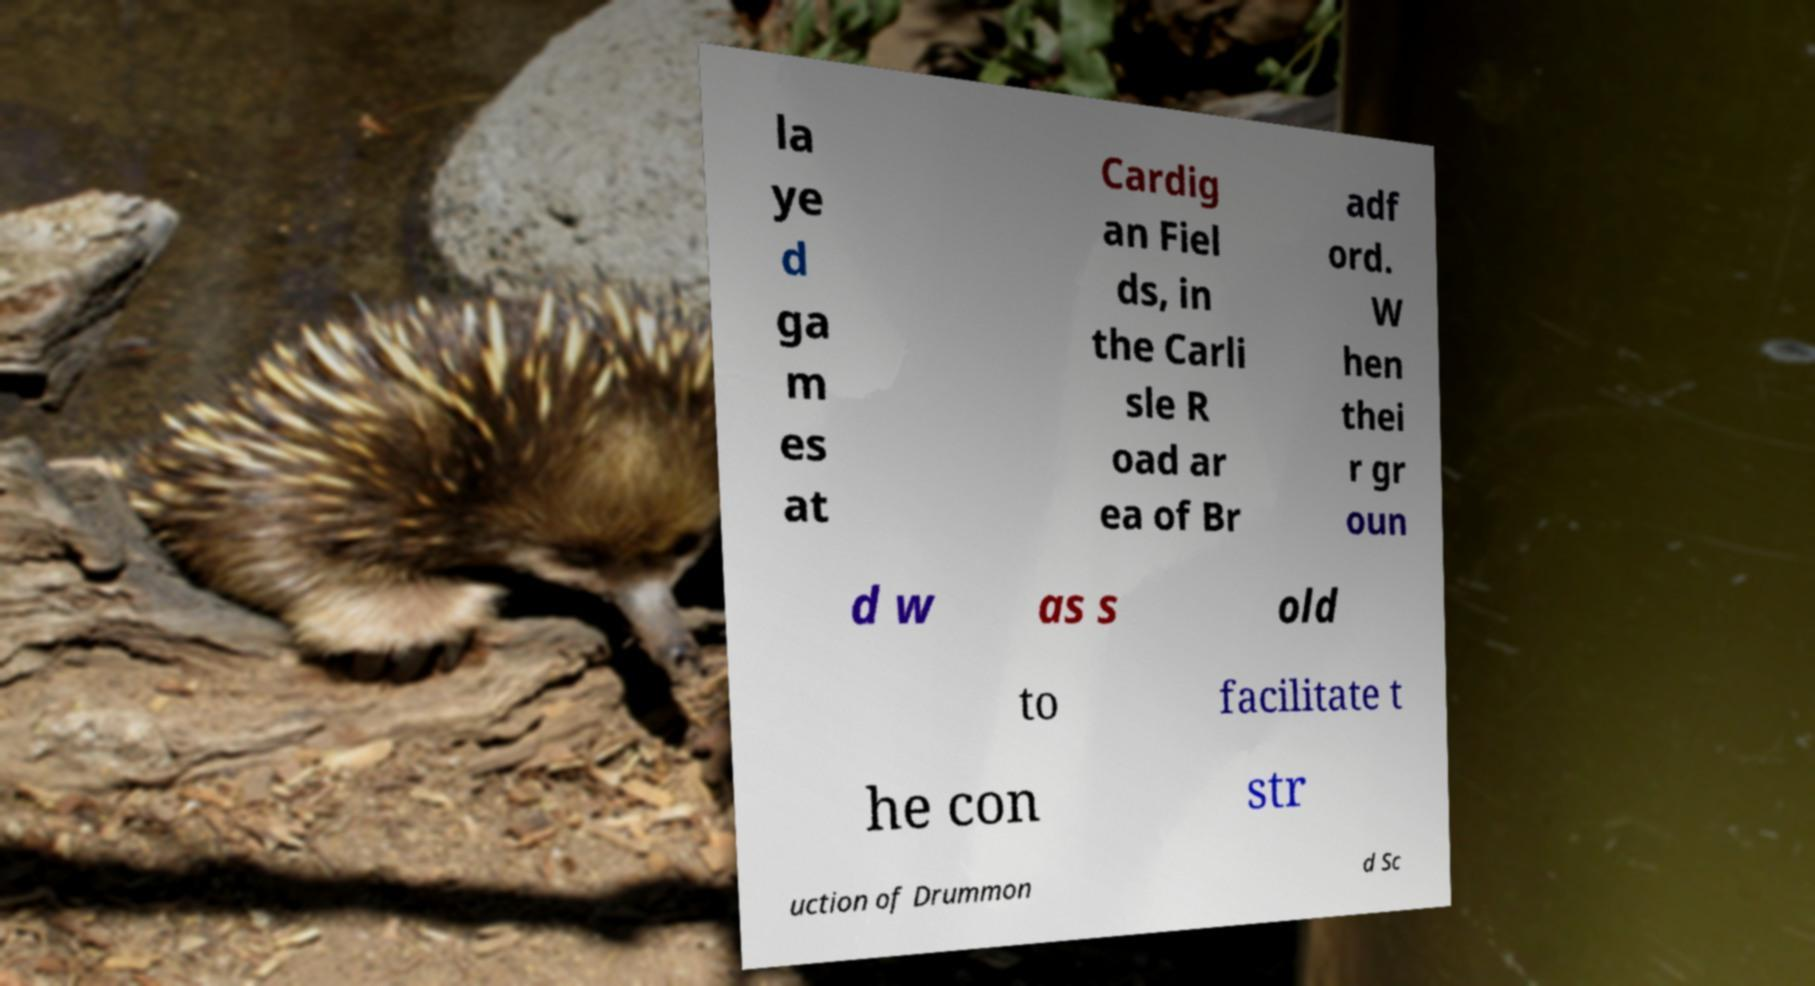Please read and relay the text visible in this image. What does it say? la ye d ga m es at Cardig an Fiel ds, in the Carli sle R oad ar ea of Br adf ord. W hen thei r gr oun d w as s old to facilitate t he con str uction of Drummon d Sc 